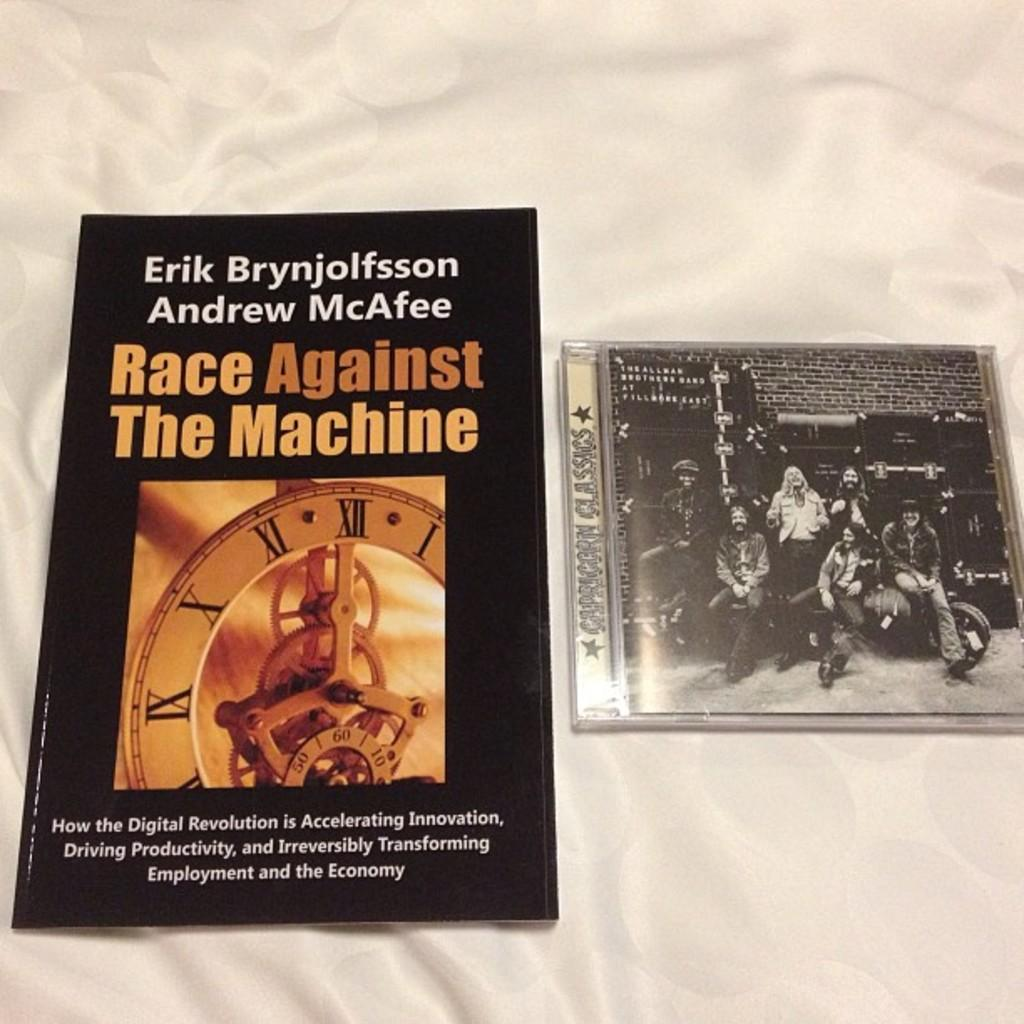<image>
Create a compact narrative representing the image presented. The two authors of this book are Erik Brynjolfsson and Andrew McAfee. 